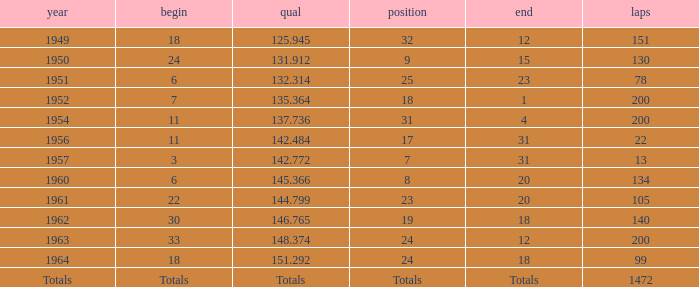Name the rank for 151 Laps 32.0. 